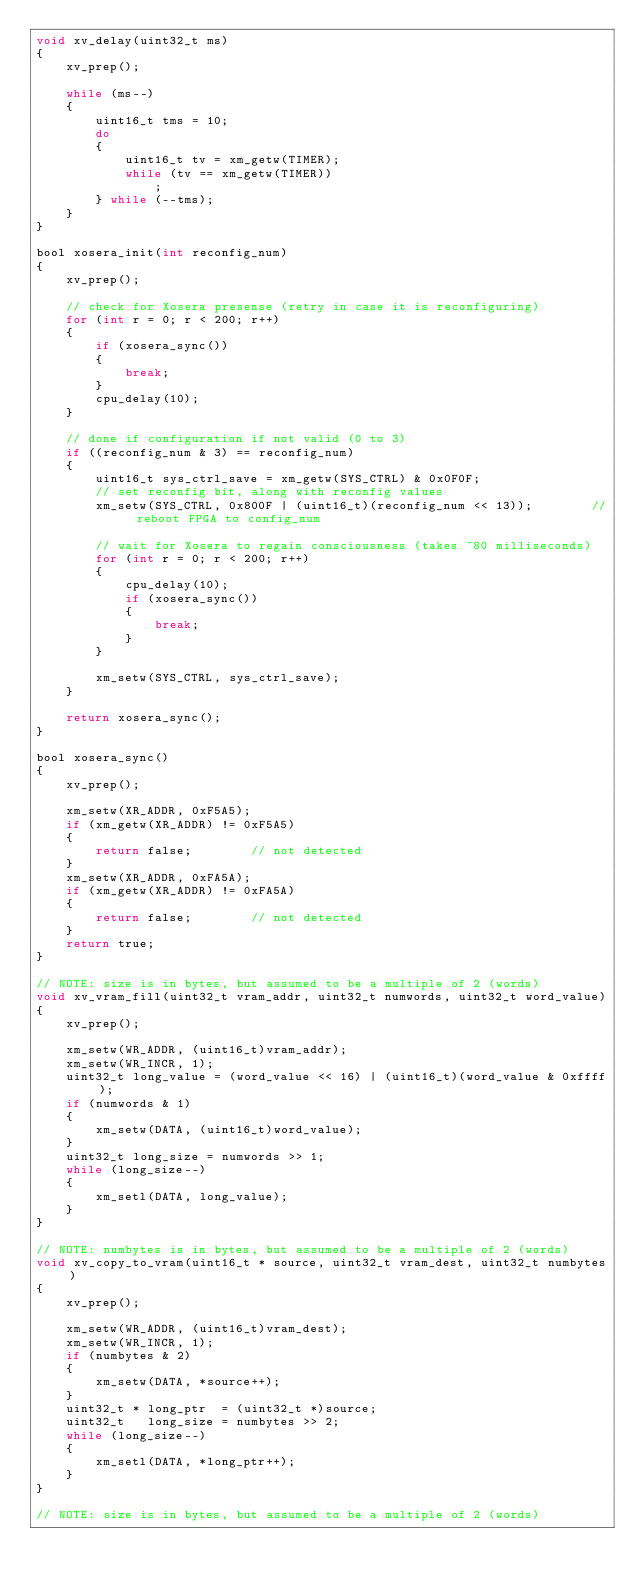Convert code to text. <code><loc_0><loc_0><loc_500><loc_500><_C_>void xv_delay(uint32_t ms)
{
    xv_prep();

    while (ms--)
    {
        uint16_t tms = 10;
        do
        {
            uint16_t tv = xm_getw(TIMER);
            while (tv == xm_getw(TIMER))
                ;
        } while (--tms);
    }
}

bool xosera_init(int reconfig_num)
{
    xv_prep();

    // check for Xosera presense (retry in case it is reconfiguring)
    for (int r = 0; r < 200; r++)
    {
        if (xosera_sync())
        {
            break;
        }
        cpu_delay(10);
    }

    // done if configuration if not valid (0 to 3)
    if ((reconfig_num & 3) == reconfig_num)
    {
        uint16_t sys_ctrl_save = xm_getw(SYS_CTRL) & 0x0F0F;
        // set reconfig bit, along with reconfig values
        xm_setw(SYS_CTRL, 0x800F | (uint16_t)(reconfig_num << 13));        // reboot FPGA to config_num

        // wait for Xosera to regain consciousness (takes ~80 milliseconds)
        for (int r = 0; r < 200; r++)
        {
            cpu_delay(10);
            if (xosera_sync())
            {
                break;
            }
        }

        xm_setw(SYS_CTRL, sys_ctrl_save);
    }

    return xosera_sync();
}

bool xosera_sync()
{
    xv_prep();

    xm_setw(XR_ADDR, 0xF5A5);
    if (xm_getw(XR_ADDR) != 0xF5A5)
    {
        return false;        // not detected
    }
    xm_setw(XR_ADDR, 0xFA5A);
    if (xm_getw(XR_ADDR) != 0xFA5A)
    {
        return false;        // not detected
    }
    return true;
}

// NOTE: size is in bytes, but assumed to be a multiple of 2 (words)
void xv_vram_fill(uint32_t vram_addr, uint32_t numwords, uint32_t word_value)
{
    xv_prep();

    xm_setw(WR_ADDR, (uint16_t)vram_addr);
    xm_setw(WR_INCR, 1);
    uint32_t long_value = (word_value << 16) | (uint16_t)(word_value & 0xffff);
    if (numwords & 1)
    {
        xm_setw(DATA, (uint16_t)word_value);
    }
    uint32_t long_size = numwords >> 1;
    while (long_size--)
    {
        xm_setl(DATA, long_value);
    }
}

// NOTE: numbytes is in bytes, but assumed to be a multiple of 2 (words)
void xv_copy_to_vram(uint16_t * source, uint32_t vram_dest, uint32_t numbytes)
{
    xv_prep();

    xm_setw(WR_ADDR, (uint16_t)vram_dest);
    xm_setw(WR_INCR, 1);
    if (numbytes & 2)
    {
        xm_setw(DATA, *source++);
    }
    uint32_t * long_ptr  = (uint32_t *)source;
    uint32_t   long_size = numbytes >> 2;
    while (long_size--)
    {
        xm_setl(DATA, *long_ptr++);
    }
}

// NOTE: size is in bytes, but assumed to be a multiple of 2 (words)</code> 